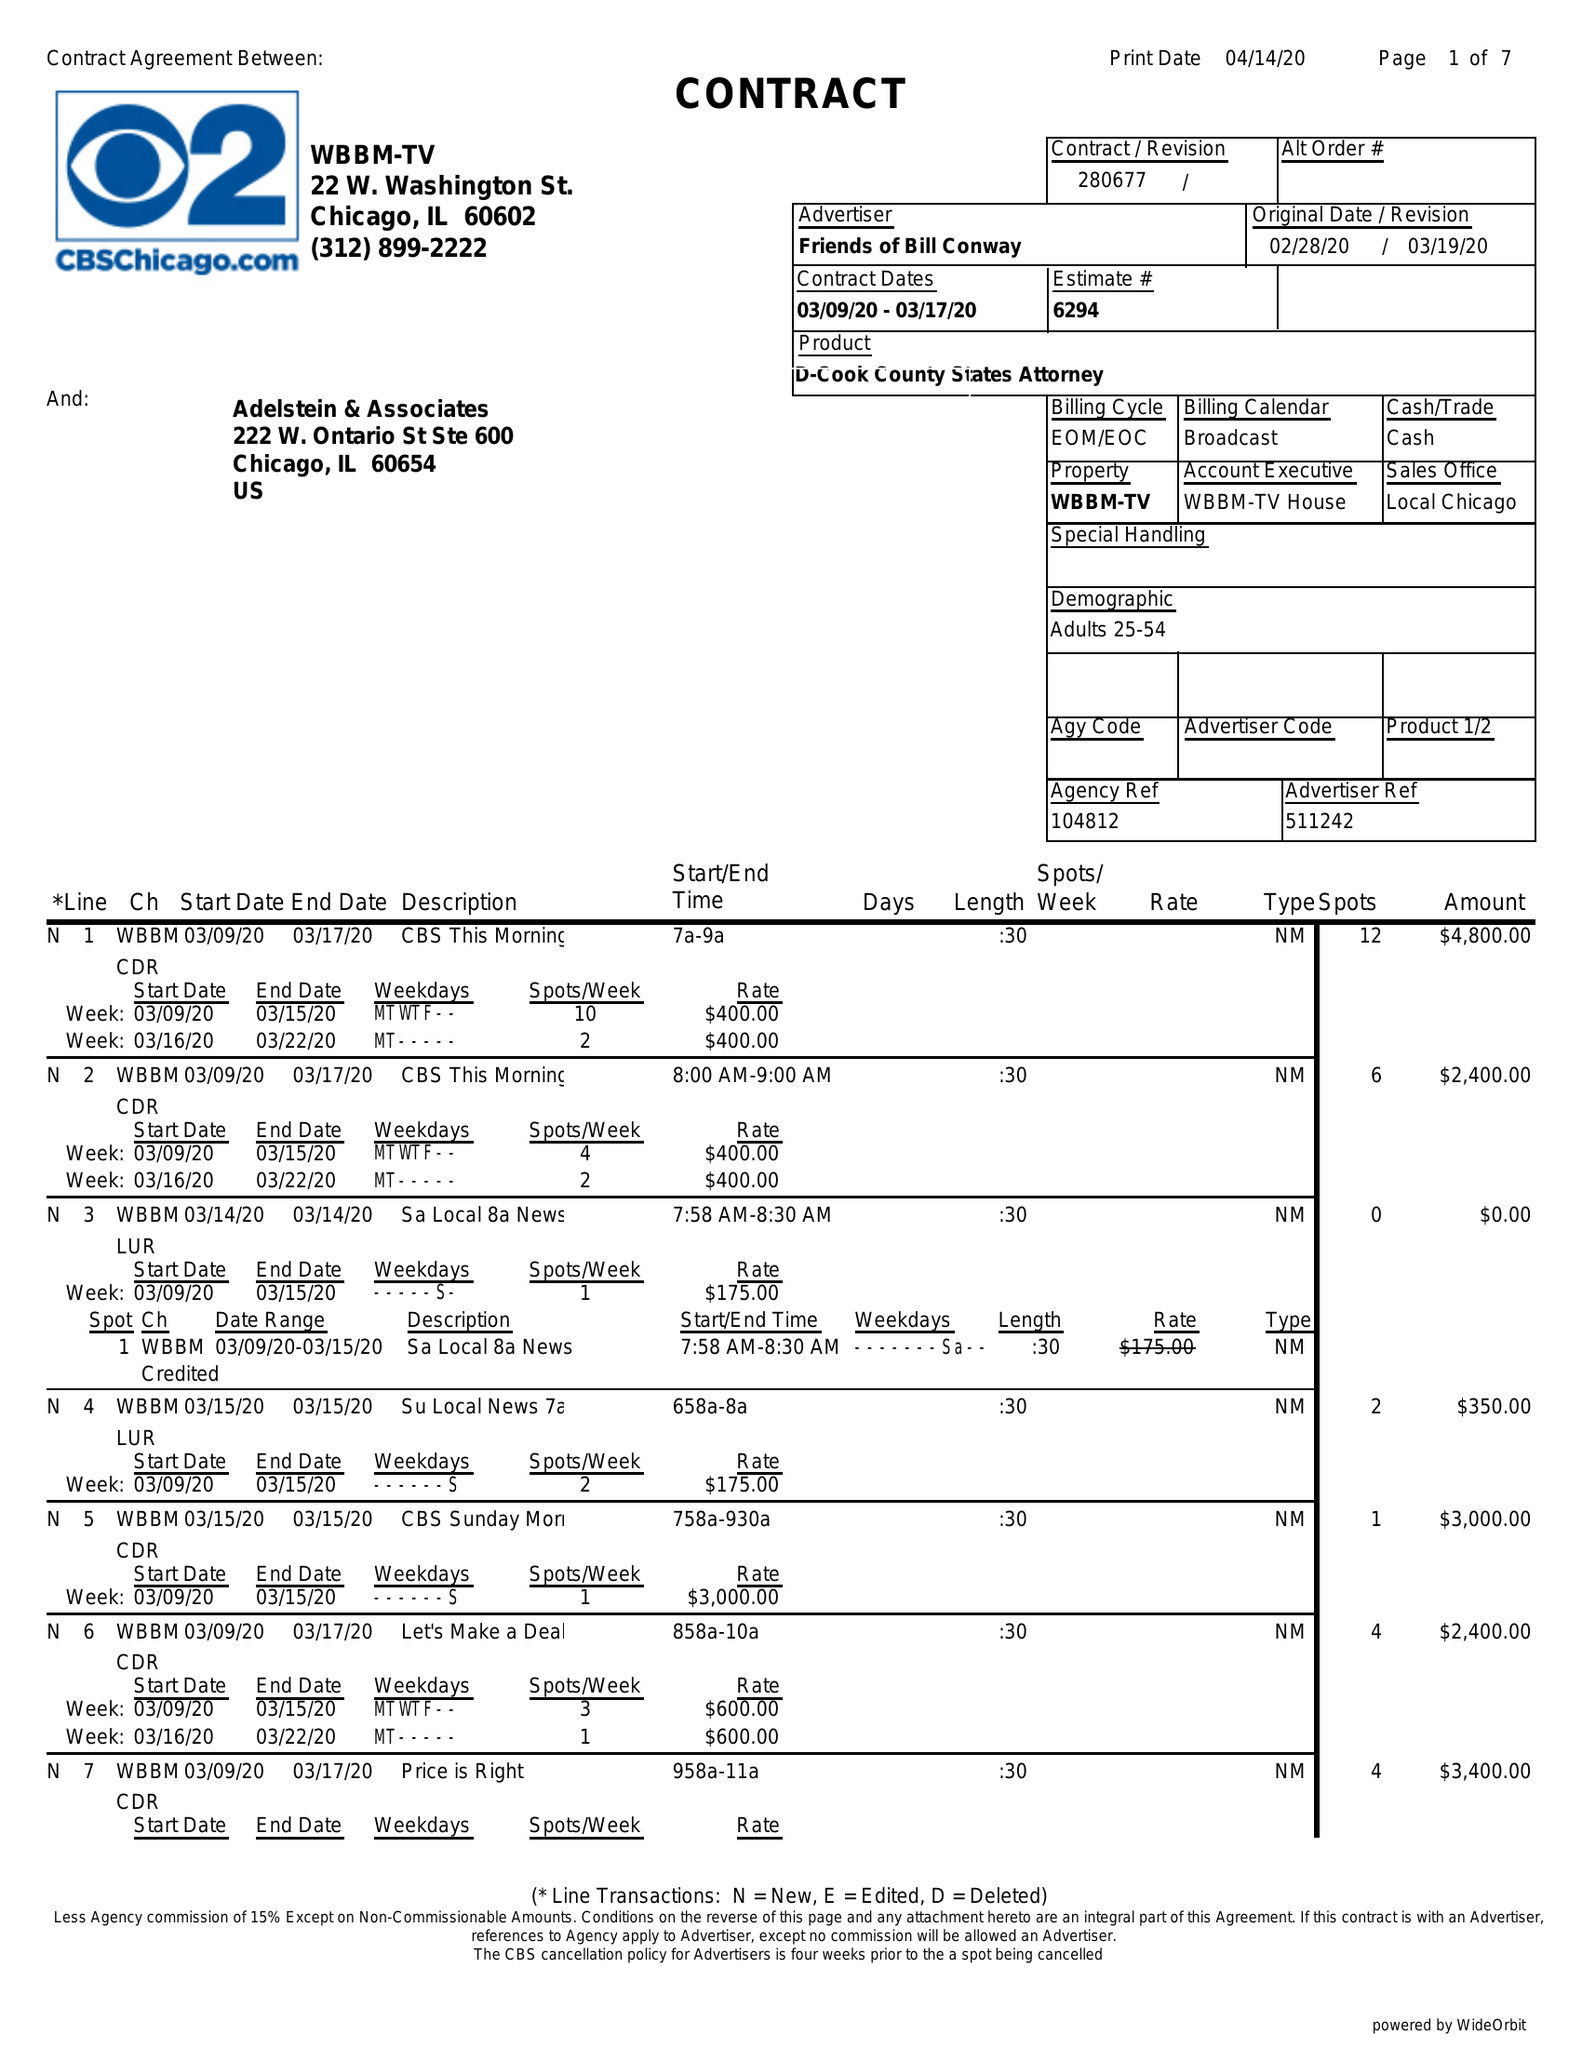What is the value for the flight_from?
Answer the question using a single word or phrase. 03/09/20 